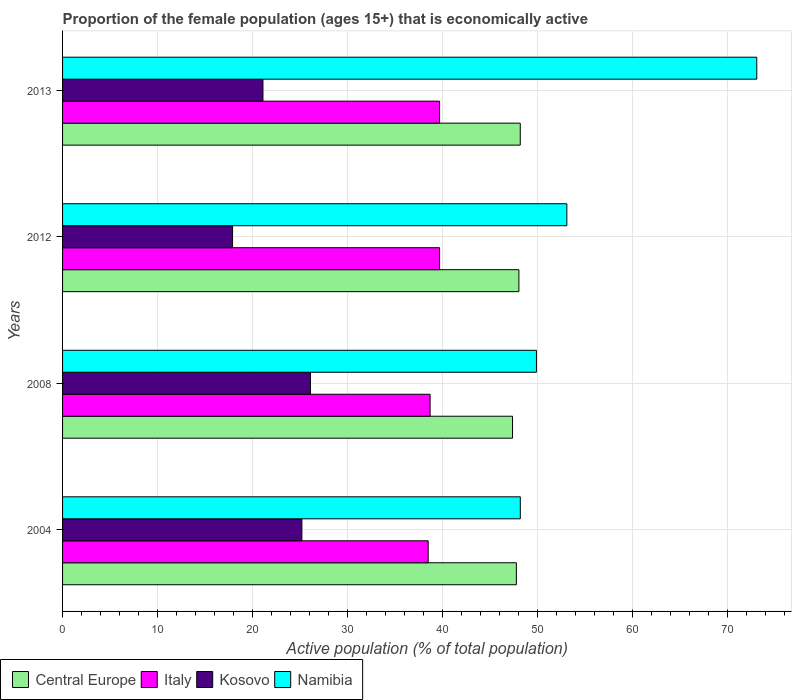How many different coloured bars are there?
Offer a terse response. 4. Are the number of bars on each tick of the Y-axis equal?
Keep it short and to the point. Yes. What is the proportion of the female population that is economically active in Kosovo in 2012?
Keep it short and to the point. 17.9. Across all years, what is the maximum proportion of the female population that is economically active in Italy?
Make the answer very short. 39.7. Across all years, what is the minimum proportion of the female population that is economically active in Italy?
Ensure brevity in your answer.  38.5. What is the total proportion of the female population that is economically active in Namibia in the graph?
Keep it short and to the point. 224.3. What is the difference between the proportion of the female population that is economically active in Kosovo in 2004 and that in 2013?
Provide a short and direct response. 4.1. What is the difference between the proportion of the female population that is economically active in Kosovo in 2008 and the proportion of the female population that is economically active in Namibia in 2012?
Ensure brevity in your answer.  -27. What is the average proportion of the female population that is economically active in Namibia per year?
Offer a very short reply. 56.07. In the year 2008, what is the difference between the proportion of the female population that is economically active in Namibia and proportion of the female population that is economically active in Kosovo?
Provide a succinct answer. 23.8. In how many years, is the proportion of the female population that is economically active in Kosovo greater than 14 %?
Your answer should be compact. 4. What is the ratio of the proportion of the female population that is economically active in Namibia in 2008 to that in 2012?
Keep it short and to the point. 0.94. Is the proportion of the female population that is economically active in Central Europe in 2004 less than that in 2008?
Make the answer very short. No. What is the difference between the highest and the second highest proportion of the female population that is economically active in Kosovo?
Make the answer very short. 0.9. What is the difference between the highest and the lowest proportion of the female population that is economically active in Kosovo?
Make the answer very short. 8.2. In how many years, is the proportion of the female population that is economically active in Central Europe greater than the average proportion of the female population that is economically active in Central Europe taken over all years?
Your answer should be compact. 2. Is it the case that in every year, the sum of the proportion of the female population that is economically active in Kosovo and proportion of the female population that is economically active in Central Europe is greater than the sum of proportion of the female population that is economically active in Italy and proportion of the female population that is economically active in Namibia?
Your answer should be compact. Yes. What does the 1st bar from the bottom in 2008 represents?
Ensure brevity in your answer.  Central Europe. Is it the case that in every year, the sum of the proportion of the female population that is economically active in Central Europe and proportion of the female population that is economically active in Kosovo is greater than the proportion of the female population that is economically active in Namibia?
Make the answer very short. No. Are all the bars in the graph horizontal?
Provide a short and direct response. Yes. What is the difference between two consecutive major ticks on the X-axis?
Offer a very short reply. 10. Does the graph contain any zero values?
Your response must be concise. No. How many legend labels are there?
Your answer should be compact. 4. How are the legend labels stacked?
Your answer should be compact. Horizontal. What is the title of the graph?
Give a very brief answer. Proportion of the female population (ages 15+) that is economically active. Does "Turkmenistan" appear as one of the legend labels in the graph?
Offer a very short reply. No. What is the label or title of the X-axis?
Offer a terse response. Active population (% of total population). What is the label or title of the Y-axis?
Ensure brevity in your answer.  Years. What is the Active population (% of total population) of Central Europe in 2004?
Offer a very short reply. 47.79. What is the Active population (% of total population) of Italy in 2004?
Offer a very short reply. 38.5. What is the Active population (% of total population) of Kosovo in 2004?
Your answer should be compact. 25.2. What is the Active population (% of total population) in Namibia in 2004?
Provide a short and direct response. 48.2. What is the Active population (% of total population) in Central Europe in 2008?
Make the answer very short. 47.38. What is the Active population (% of total population) of Italy in 2008?
Offer a very short reply. 38.7. What is the Active population (% of total population) in Kosovo in 2008?
Keep it short and to the point. 26.1. What is the Active population (% of total population) in Namibia in 2008?
Your response must be concise. 49.9. What is the Active population (% of total population) of Central Europe in 2012?
Make the answer very short. 48.05. What is the Active population (% of total population) in Italy in 2012?
Offer a terse response. 39.7. What is the Active population (% of total population) of Kosovo in 2012?
Ensure brevity in your answer.  17.9. What is the Active population (% of total population) in Namibia in 2012?
Provide a succinct answer. 53.1. What is the Active population (% of total population) in Central Europe in 2013?
Keep it short and to the point. 48.2. What is the Active population (% of total population) in Italy in 2013?
Provide a short and direct response. 39.7. What is the Active population (% of total population) in Kosovo in 2013?
Your answer should be very brief. 21.1. What is the Active population (% of total population) of Namibia in 2013?
Give a very brief answer. 73.1. Across all years, what is the maximum Active population (% of total population) of Central Europe?
Ensure brevity in your answer.  48.2. Across all years, what is the maximum Active population (% of total population) in Italy?
Provide a short and direct response. 39.7. Across all years, what is the maximum Active population (% of total population) in Kosovo?
Give a very brief answer. 26.1. Across all years, what is the maximum Active population (% of total population) of Namibia?
Your answer should be compact. 73.1. Across all years, what is the minimum Active population (% of total population) in Central Europe?
Provide a short and direct response. 47.38. Across all years, what is the minimum Active population (% of total population) in Italy?
Make the answer very short. 38.5. Across all years, what is the minimum Active population (% of total population) in Kosovo?
Ensure brevity in your answer.  17.9. Across all years, what is the minimum Active population (% of total population) of Namibia?
Offer a terse response. 48.2. What is the total Active population (% of total population) in Central Europe in the graph?
Offer a very short reply. 191.41. What is the total Active population (% of total population) of Italy in the graph?
Give a very brief answer. 156.6. What is the total Active population (% of total population) of Kosovo in the graph?
Provide a succinct answer. 90.3. What is the total Active population (% of total population) of Namibia in the graph?
Ensure brevity in your answer.  224.3. What is the difference between the Active population (% of total population) in Central Europe in 2004 and that in 2008?
Provide a succinct answer. 0.41. What is the difference between the Active population (% of total population) of Italy in 2004 and that in 2008?
Ensure brevity in your answer.  -0.2. What is the difference between the Active population (% of total population) in Namibia in 2004 and that in 2008?
Your response must be concise. -1.7. What is the difference between the Active population (% of total population) in Central Europe in 2004 and that in 2012?
Ensure brevity in your answer.  -0.27. What is the difference between the Active population (% of total population) in Italy in 2004 and that in 2012?
Give a very brief answer. -1.2. What is the difference between the Active population (% of total population) in Namibia in 2004 and that in 2012?
Offer a very short reply. -4.9. What is the difference between the Active population (% of total population) of Central Europe in 2004 and that in 2013?
Provide a succinct answer. -0.41. What is the difference between the Active population (% of total population) in Italy in 2004 and that in 2013?
Your answer should be compact. -1.2. What is the difference between the Active population (% of total population) in Namibia in 2004 and that in 2013?
Offer a very short reply. -24.9. What is the difference between the Active population (% of total population) of Central Europe in 2008 and that in 2012?
Keep it short and to the point. -0.67. What is the difference between the Active population (% of total population) in Italy in 2008 and that in 2012?
Offer a very short reply. -1. What is the difference between the Active population (% of total population) of Kosovo in 2008 and that in 2012?
Provide a succinct answer. 8.2. What is the difference between the Active population (% of total population) of Namibia in 2008 and that in 2012?
Ensure brevity in your answer.  -3.2. What is the difference between the Active population (% of total population) of Central Europe in 2008 and that in 2013?
Your answer should be very brief. -0.82. What is the difference between the Active population (% of total population) of Kosovo in 2008 and that in 2013?
Your answer should be very brief. 5. What is the difference between the Active population (% of total population) of Namibia in 2008 and that in 2013?
Make the answer very short. -23.2. What is the difference between the Active population (% of total population) of Central Europe in 2012 and that in 2013?
Your answer should be compact. -0.14. What is the difference between the Active population (% of total population) of Namibia in 2012 and that in 2013?
Your response must be concise. -20. What is the difference between the Active population (% of total population) of Central Europe in 2004 and the Active population (% of total population) of Italy in 2008?
Make the answer very short. 9.09. What is the difference between the Active population (% of total population) in Central Europe in 2004 and the Active population (% of total population) in Kosovo in 2008?
Your answer should be very brief. 21.69. What is the difference between the Active population (% of total population) in Central Europe in 2004 and the Active population (% of total population) in Namibia in 2008?
Offer a very short reply. -2.11. What is the difference between the Active population (% of total population) of Kosovo in 2004 and the Active population (% of total population) of Namibia in 2008?
Make the answer very short. -24.7. What is the difference between the Active population (% of total population) in Central Europe in 2004 and the Active population (% of total population) in Italy in 2012?
Offer a very short reply. 8.09. What is the difference between the Active population (% of total population) of Central Europe in 2004 and the Active population (% of total population) of Kosovo in 2012?
Provide a succinct answer. 29.89. What is the difference between the Active population (% of total population) in Central Europe in 2004 and the Active population (% of total population) in Namibia in 2012?
Your answer should be compact. -5.31. What is the difference between the Active population (% of total population) of Italy in 2004 and the Active population (% of total population) of Kosovo in 2012?
Offer a terse response. 20.6. What is the difference between the Active population (% of total population) of Italy in 2004 and the Active population (% of total population) of Namibia in 2012?
Your answer should be very brief. -14.6. What is the difference between the Active population (% of total population) in Kosovo in 2004 and the Active population (% of total population) in Namibia in 2012?
Provide a short and direct response. -27.9. What is the difference between the Active population (% of total population) of Central Europe in 2004 and the Active population (% of total population) of Italy in 2013?
Keep it short and to the point. 8.09. What is the difference between the Active population (% of total population) in Central Europe in 2004 and the Active population (% of total population) in Kosovo in 2013?
Offer a terse response. 26.69. What is the difference between the Active population (% of total population) in Central Europe in 2004 and the Active population (% of total population) in Namibia in 2013?
Offer a very short reply. -25.31. What is the difference between the Active population (% of total population) of Italy in 2004 and the Active population (% of total population) of Kosovo in 2013?
Offer a very short reply. 17.4. What is the difference between the Active population (% of total population) in Italy in 2004 and the Active population (% of total population) in Namibia in 2013?
Offer a very short reply. -34.6. What is the difference between the Active population (% of total population) of Kosovo in 2004 and the Active population (% of total population) of Namibia in 2013?
Your answer should be compact. -47.9. What is the difference between the Active population (% of total population) in Central Europe in 2008 and the Active population (% of total population) in Italy in 2012?
Give a very brief answer. 7.68. What is the difference between the Active population (% of total population) of Central Europe in 2008 and the Active population (% of total population) of Kosovo in 2012?
Give a very brief answer. 29.48. What is the difference between the Active population (% of total population) in Central Europe in 2008 and the Active population (% of total population) in Namibia in 2012?
Make the answer very short. -5.72. What is the difference between the Active population (% of total population) in Italy in 2008 and the Active population (% of total population) in Kosovo in 2012?
Your answer should be very brief. 20.8. What is the difference between the Active population (% of total population) of Italy in 2008 and the Active population (% of total population) of Namibia in 2012?
Provide a short and direct response. -14.4. What is the difference between the Active population (% of total population) in Central Europe in 2008 and the Active population (% of total population) in Italy in 2013?
Offer a terse response. 7.68. What is the difference between the Active population (% of total population) of Central Europe in 2008 and the Active population (% of total population) of Kosovo in 2013?
Make the answer very short. 26.28. What is the difference between the Active population (% of total population) of Central Europe in 2008 and the Active population (% of total population) of Namibia in 2013?
Ensure brevity in your answer.  -25.72. What is the difference between the Active population (% of total population) of Italy in 2008 and the Active population (% of total population) of Namibia in 2013?
Make the answer very short. -34.4. What is the difference between the Active population (% of total population) in Kosovo in 2008 and the Active population (% of total population) in Namibia in 2013?
Provide a succinct answer. -47. What is the difference between the Active population (% of total population) in Central Europe in 2012 and the Active population (% of total population) in Italy in 2013?
Give a very brief answer. 8.35. What is the difference between the Active population (% of total population) in Central Europe in 2012 and the Active population (% of total population) in Kosovo in 2013?
Give a very brief answer. 26.95. What is the difference between the Active population (% of total population) of Central Europe in 2012 and the Active population (% of total population) of Namibia in 2013?
Provide a succinct answer. -25.05. What is the difference between the Active population (% of total population) of Italy in 2012 and the Active population (% of total population) of Kosovo in 2013?
Offer a terse response. 18.6. What is the difference between the Active population (% of total population) in Italy in 2012 and the Active population (% of total population) in Namibia in 2013?
Give a very brief answer. -33.4. What is the difference between the Active population (% of total population) of Kosovo in 2012 and the Active population (% of total population) of Namibia in 2013?
Keep it short and to the point. -55.2. What is the average Active population (% of total population) in Central Europe per year?
Make the answer very short. 47.85. What is the average Active population (% of total population) in Italy per year?
Provide a short and direct response. 39.15. What is the average Active population (% of total population) of Kosovo per year?
Your answer should be compact. 22.57. What is the average Active population (% of total population) in Namibia per year?
Make the answer very short. 56.08. In the year 2004, what is the difference between the Active population (% of total population) of Central Europe and Active population (% of total population) of Italy?
Offer a very short reply. 9.29. In the year 2004, what is the difference between the Active population (% of total population) in Central Europe and Active population (% of total population) in Kosovo?
Offer a very short reply. 22.59. In the year 2004, what is the difference between the Active population (% of total population) of Central Europe and Active population (% of total population) of Namibia?
Offer a very short reply. -0.41. In the year 2004, what is the difference between the Active population (% of total population) of Italy and Active population (% of total population) of Namibia?
Offer a terse response. -9.7. In the year 2004, what is the difference between the Active population (% of total population) of Kosovo and Active population (% of total population) of Namibia?
Keep it short and to the point. -23. In the year 2008, what is the difference between the Active population (% of total population) in Central Europe and Active population (% of total population) in Italy?
Provide a succinct answer. 8.68. In the year 2008, what is the difference between the Active population (% of total population) in Central Europe and Active population (% of total population) in Kosovo?
Make the answer very short. 21.28. In the year 2008, what is the difference between the Active population (% of total population) in Central Europe and Active population (% of total population) in Namibia?
Your answer should be very brief. -2.52. In the year 2008, what is the difference between the Active population (% of total population) in Italy and Active population (% of total population) in Namibia?
Offer a terse response. -11.2. In the year 2008, what is the difference between the Active population (% of total population) of Kosovo and Active population (% of total population) of Namibia?
Provide a succinct answer. -23.8. In the year 2012, what is the difference between the Active population (% of total population) of Central Europe and Active population (% of total population) of Italy?
Your answer should be compact. 8.35. In the year 2012, what is the difference between the Active population (% of total population) in Central Europe and Active population (% of total population) in Kosovo?
Ensure brevity in your answer.  30.15. In the year 2012, what is the difference between the Active population (% of total population) in Central Europe and Active population (% of total population) in Namibia?
Offer a very short reply. -5.05. In the year 2012, what is the difference between the Active population (% of total population) of Italy and Active population (% of total population) of Kosovo?
Ensure brevity in your answer.  21.8. In the year 2012, what is the difference between the Active population (% of total population) of Kosovo and Active population (% of total population) of Namibia?
Keep it short and to the point. -35.2. In the year 2013, what is the difference between the Active population (% of total population) of Central Europe and Active population (% of total population) of Italy?
Offer a terse response. 8.5. In the year 2013, what is the difference between the Active population (% of total population) in Central Europe and Active population (% of total population) in Kosovo?
Keep it short and to the point. 27.1. In the year 2013, what is the difference between the Active population (% of total population) in Central Europe and Active population (% of total population) in Namibia?
Provide a succinct answer. -24.9. In the year 2013, what is the difference between the Active population (% of total population) in Italy and Active population (% of total population) in Kosovo?
Offer a terse response. 18.6. In the year 2013, what is the difference between the Active population (% of total population) in Italy and Active population (% of total population) in Namibia?
Your answer should be compact. -33.4. In the year 2013, what is the difference between the Active population (% of total population) in Kosovo and Active population (% of total population) in Namibia?
Make the answer very short. -52. What is the ratio of the Active population (% of total population) in Central Europe in 2004 to that in 2008?
Provide a short and direct response. 1.01. What is the ratio of the Active population (% of total population) of Kosovo in 2004 to that in 2008?
Offer a terse response. 0.97. What is the ratio of the Active population (% of total population) of Namibia in 2004 to that in 2008?
Your answer should be very brief. 0.97. What is the ratio of the Active population (% of total population) of Italy in 2004 to that in 2012?
Your answer should be very brief. 0.97. What is the ratio of the Active population (% of total population) of Kosovo in 2004 to that in 2012?
Ensure brevity in your answer.  1.41. What is the ratio of the Active population (% of total population) in Namibia in 2004 to that in 2012?
Offer a terse response. 0.91. What is the ratio of the Active population (% of total population) in Italy in 2004 to that in 2013?
Give a very brief answer. 0.97. What is the ratio of the Active population (% of total population) in Kosovo in 2004 to that in 2013?
Offer a very short reply. 1.19. What is the ratio of the Active population (% of total population) in Namibia in 2004 to that in 2013?
Your answer should be compact. 0.66. What is the ratio of the Active population (% of total population) in Italy in 2008 to that in 2012?
Keep it short and to the point. 0.97. What is the ratio of the Active population (% of total population) in Kosovo in 2008 to that in 2012?
Make the answer very short. 1.46. What is the ratio of the Active population (% of total population) of Namibia in 2008 to that in 2012?
Give a very brief answer. 0.94. What is the ratio of the Active population (% of total population) of Central Europe in 2008 to that in 2013?
Ensure brevity in your answer.  0.98. What is the ratio of the Active population (% of total population) in Italy in 2008 to that in 2013?
Keep it short and to the point. 0.97. What is the ratio of the Active population (% of total population) of Kosovo in 2008 to that in 2013?
Ensure brevity in your answer.  1.24. What is the ratio of the Active population (% of total population) of Namibia in 2008 to that in 2013?
Provide a succinct answer. 0.68. What is the ratio of the Active population (% of total population) of Central Europe in 2012 to that in 2013?
Offer a terse response. 1. What is the ratio of the Active population (% of total population) of Italy in 2012 to that in 2013?
Ensure brevity in your answer.  1. What is the ratio of the Active population (% of total population) in Kosovo in 2012 to that in 2013?
Provide a short and direct response. 0.85. What is the ratio of the Active population (% of total population) of Namibia in 2012 to that in 2013?
Your response must be concise. 0.73. What is the difference between the highest and the second highest Active population (% of total population) in Central Europe?
Ensure brevity in your answer.  0.14. What is the difference between the highest and the second highest Active population (% of total population) of Kosovo?
Your answer should be very brief. 0.9. What is the difference between the highest and the second highest Active population (% of total population) in Namibia?
Offer a very short reply. 20. What is the difference between the highest and the lowest Active population (% of total population) of Central Europe?
Provide a succinct answer. 0.82. What is the difference between the highest and the lowest Active population (% of total population) in Namibia?
Offer a very short reply. 24.9. 